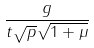Convert formula to latex. <formula><loc_0><loc_0><loc_500><loc_500>\frac { g } { t \sqrt { p } \sqrt { 1 + \mu } }</formula> 